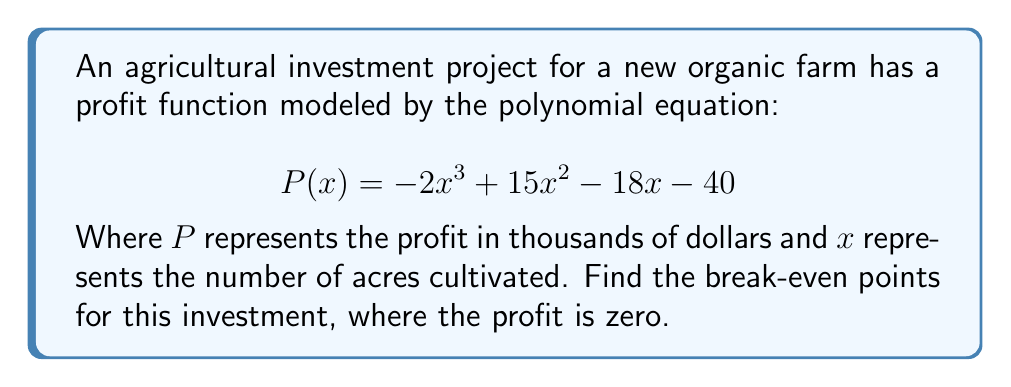What is the answer to this math problem? To find the break-even points, we need to solve the equation $P(x) = 0$:

1) Set up the equation:
   $$-2x^3 + 15x^2 - 18x - 40 = 0$$

2) This is a cubic equation. We can solve it by factoring.

3) First, let's check if there's a common factor:
   There isn't, so we proceed to the next step.

4) Try to guess one root. By inspection or trial and error, we can find that $x = 4$ is a solution.

5) Divide the polynomial by $(x - 4)$ using polynomial long division:
   $$-2x^3 + 15x^2 - 18x - 40 = (x - 4)(-2x^2 + 7x + 10)$$

6) Now we have:
   $$(x - 4)(-2x^2 + 7x + 10) = 0$$

7) Factor the quadratic term $(-2x^2 + 7x + 10)$:
   $$-2x^2 + 7x + 10 = -(2x^2 - 7x - 10) = -(2x + 5)(x - 2)$$

8) Our final factored equation is:
   $$(x - 4)(-(2x + 5)(x - 2)) = 0$$

9) By the zero product property, the solutions are:
   $x - 4 = 0$, or $-(2x + 5) = 0$, or $x - 2 = 0$

10) Solve each:
    $x = 4$, or $x = -\frac{5}{2}$, or $x = 2$

11) Check the domain: Since $x$ represents acres, negative values don't make sense in this context. We discard $x = -\frac{5}{2}$.

Therefore, the break-even points occur at 2 acres and 4 acres.
Answer: 2 acres and 4 acres 